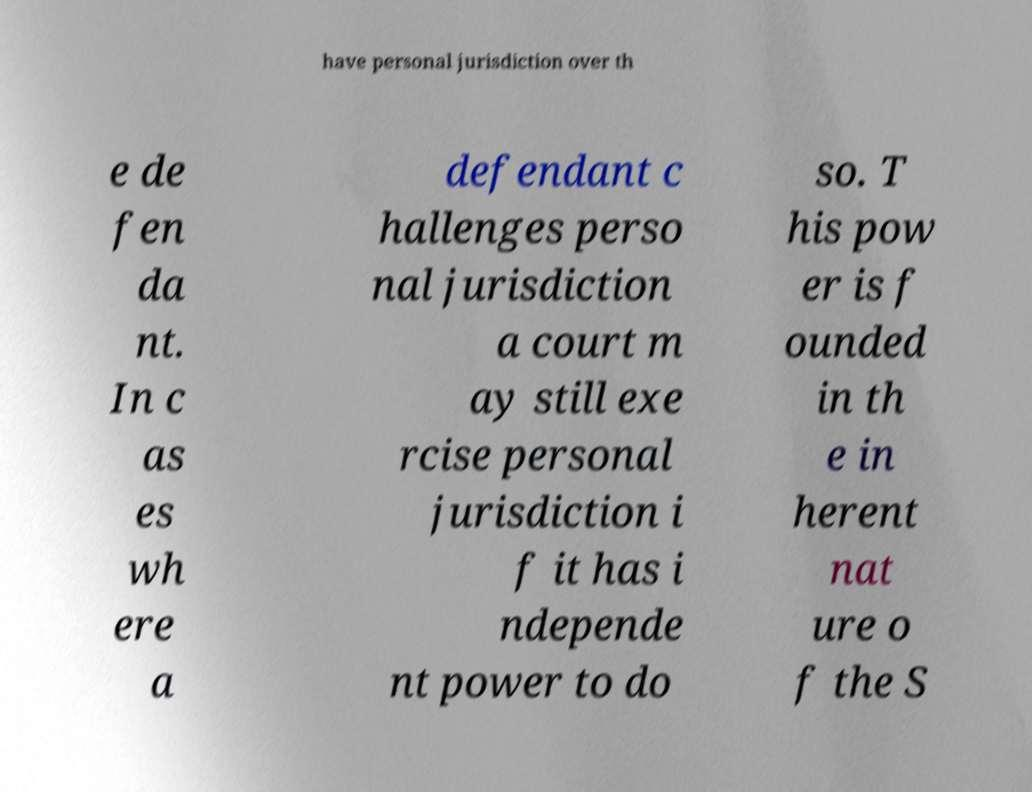For documentation purposes, I need the text within this image transcribed. Could you provide that? have personal jurisdiction over th e de fen da nt. In c as es wh ere a defendant c hallenges perso nal jurisdiction a court m ay still exe rcise personal jurisdiction i f it has i ndepende nt power to do so. T his pow er is f ounded in th e in herent nat ure o f the S 